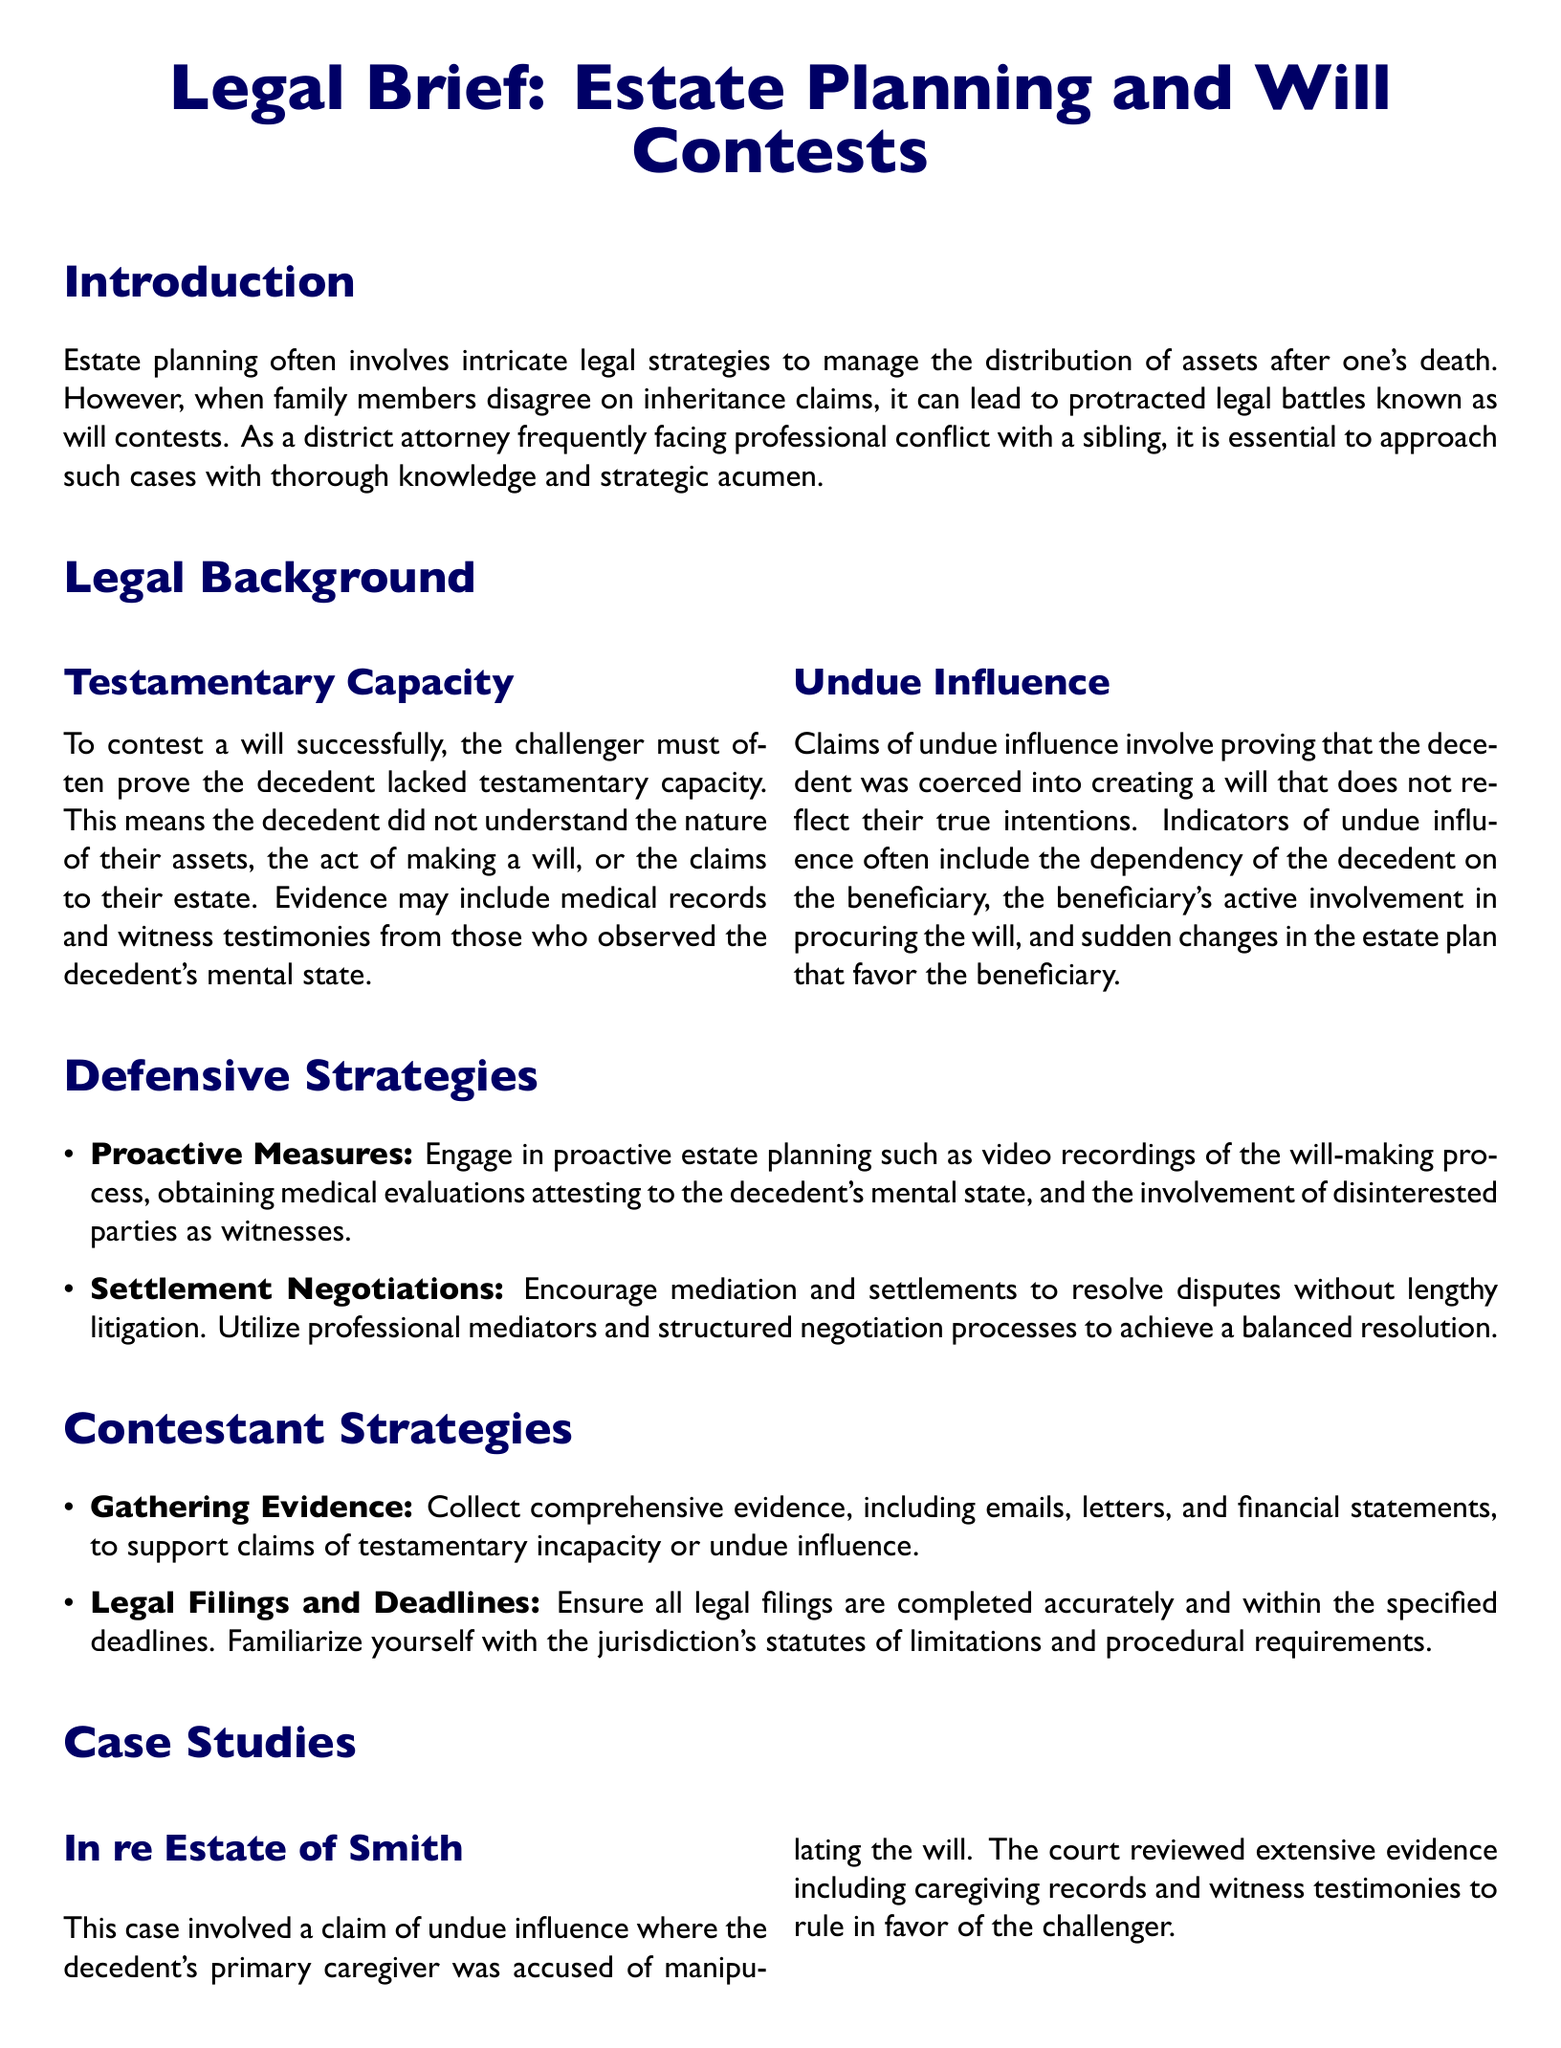What is the primary legal focus of the document? The primary legal focus of the document is the intricacies of estate planning and will contests, especially in cases where family members disagree.
Answer: Estate planning and will contests Which key term refers to the mental capacity required to make a will? The key term signifies the necessary cognitive ability of the decedent to understand their actions in making a will.
Answer: Testamentary capacity What should be gathered to support claims of undue influence? Evidence supporting claims of undue influence typically includes various forms of communications and financial documents.
Answer: Emails, letters, and financial statements What was the outcome of the case "In re Estate of Smith"? The outcome was a ruling made by the court in favor of the challenger, based on evidence of undue influence.
Answer: Ruled in favor of the challenger What type of strategies are encouraged to resolve inheritance disputes without litigation? The document advises using a specific method to facilitate amicable resolutions in inheritance disagreements.
Answer: Settlement negotiations What significant factor did medical evaluations contribute to in Doe v. Doe? Medical evaluations played a critical role in verifying the decedent's mental state prior to signing the will.
Answer: Affirming the decedent's mental state What proactive measure can be taken during the will-making process? One proactive measure that can help safeguard against future disputes is a specific type of documentation utilized during the will's creation.
Answer: Video recordings What are two types of strategies outlined for defending or contesting inheritance claims? The document identifies proactive measures and another method to mitigate legal conflict regarding inheritance claims.
Answer: Proactive measures and settlement negotiations 